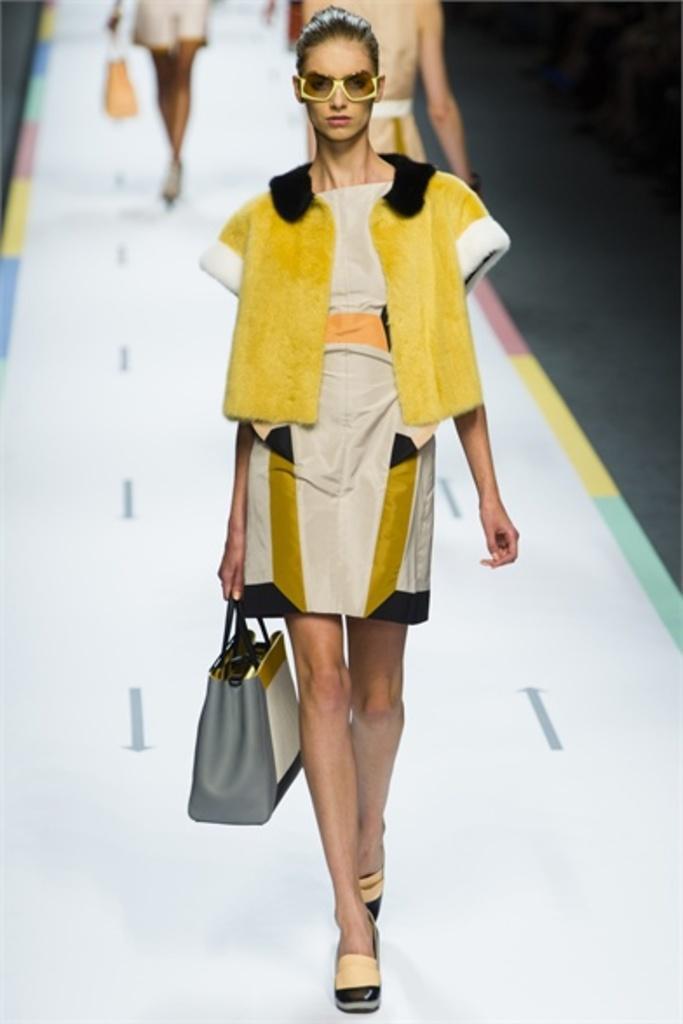In one or two sentences, can you explain what this image depicts? In this image I can see a woman with white and yellow dress. One person is holding the grey color bag and also she is wearing the sandals. In the back there are few more people walking and they are also holding the bag. 